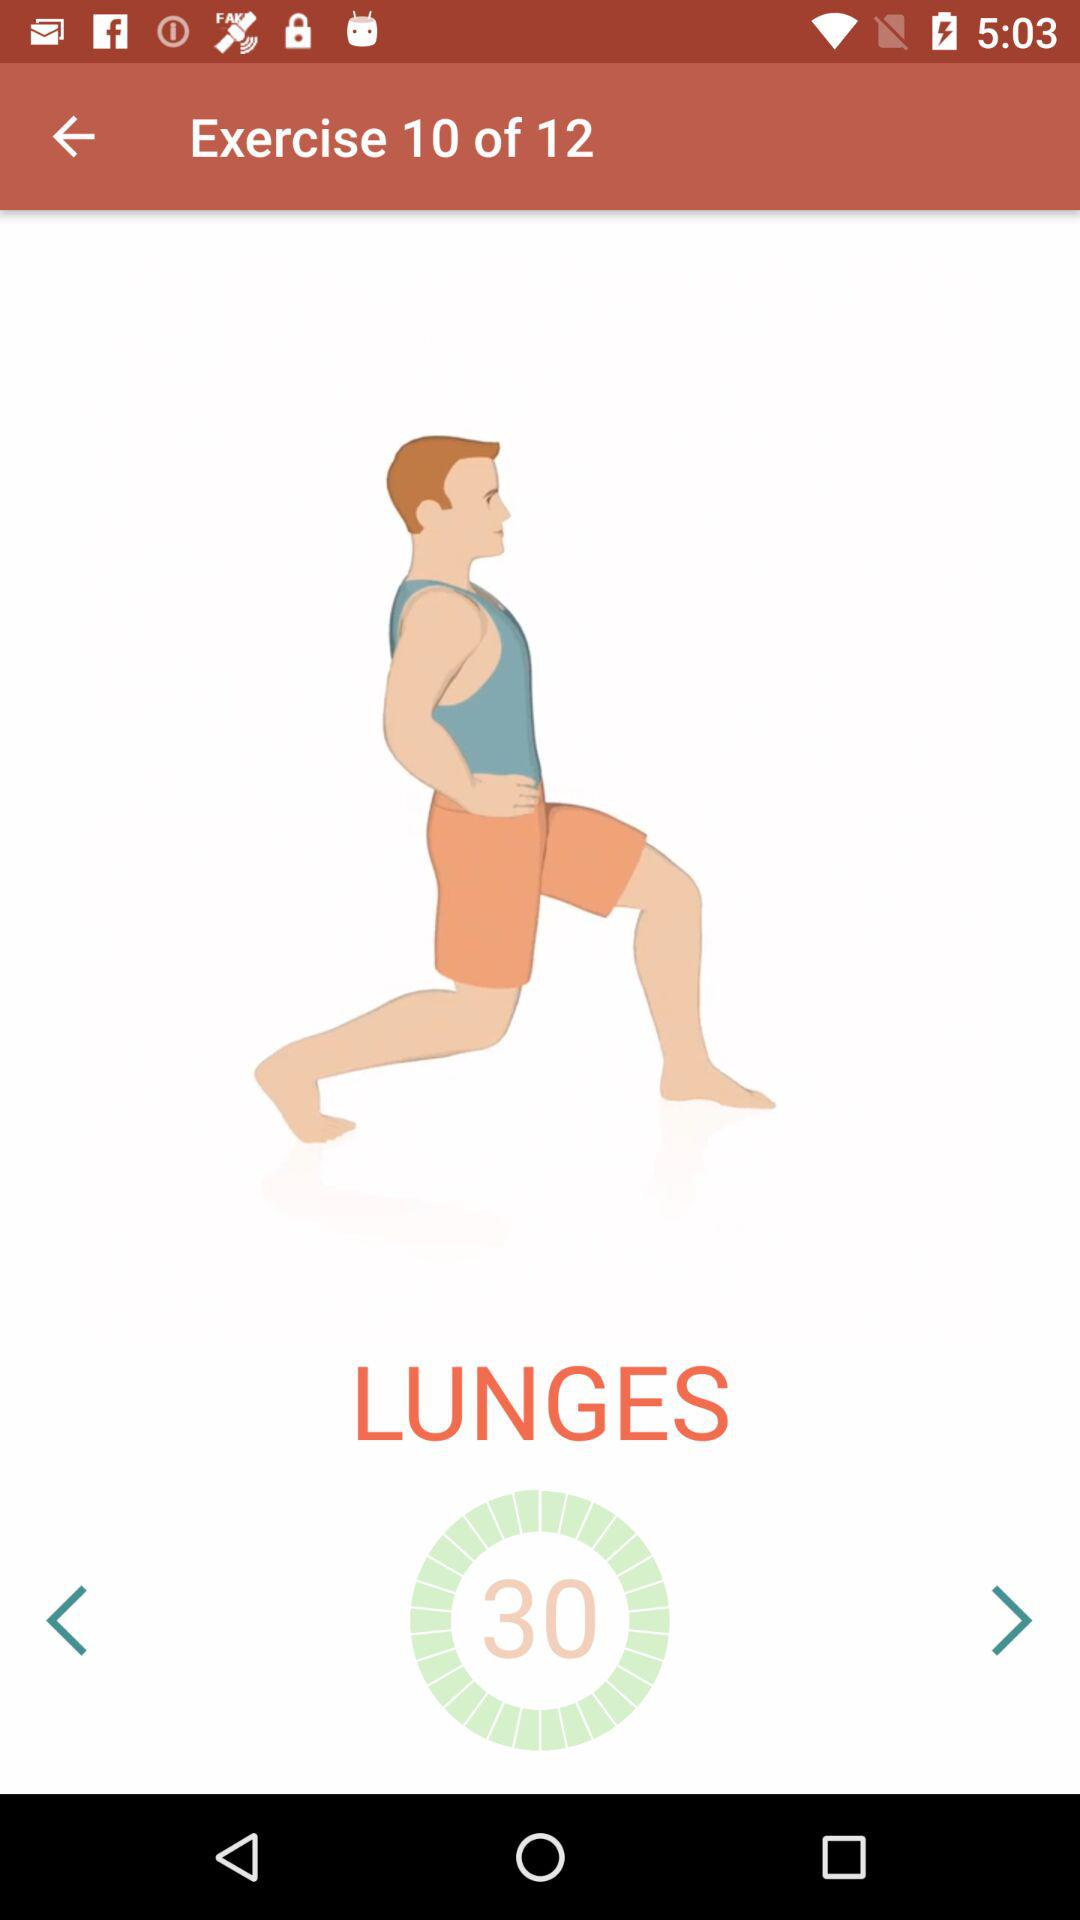What is the current exercise number? The current exercise number is 10. 